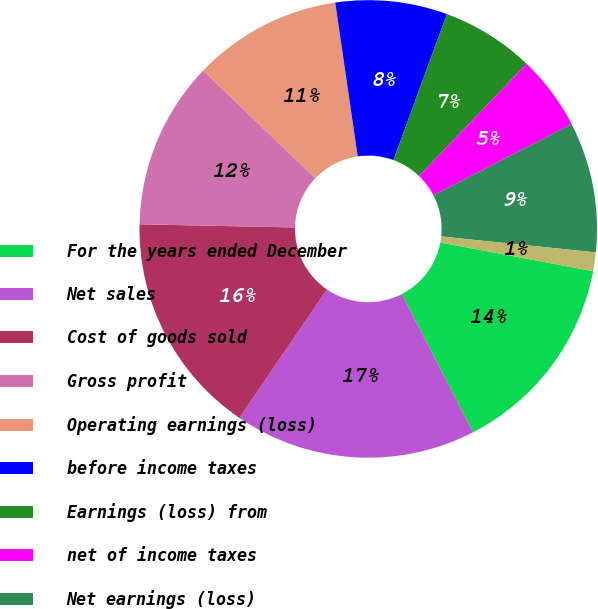<chart> <loc_0><loc_0><loc_500><loc_500><pie_chart><fcel>For the years ended December<fcel>Net sales<fcel>Cost of goods sold<fcel>Gross profit<fcel>Operating earnings (loss)<fcel>before income taxes<fcel>Earnings (loss) from<fcel>net of income taxes<fcel>Net earnings (loss)<fcel>Continuing operations<nl><fcel>14.47%<fcel>17.1%<fcel>15.79%<fcel>11.84%<fcel>10.53%<fcel>7.89%<fcel>6.58%<fcel>5.26%<fcel>9.21%<fcel>1.32%<nl></chart> 